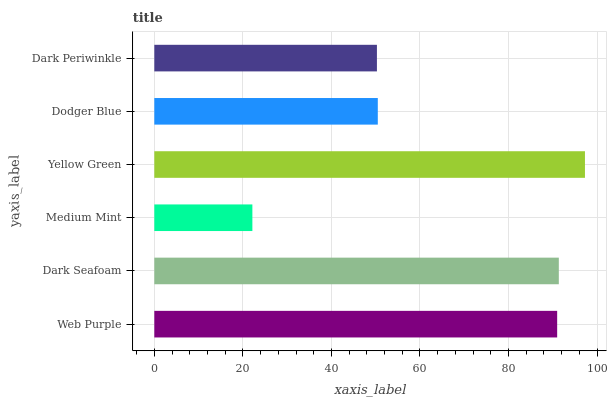Is Medium Mint the minimum?
Answer yes or no. Yes. Is Yellow Green the maximum?
Answer yes or no. Yes. Is Dark Seafoam the minimum?
Answer yes or no. No. Is Dark Seafoam the maximum?
Answer yes or no. No. Is Dark Seafoam greater than Web Purple?
Answer yes or no. Yes. Is Web Purple less than Dark Seafoam?
Answer yes or no. Yes. Is Web Purple greater than Dark Seafoam?
Answer yes or no. No. Is Dark Seafoam less than Web Purple?
Answer yes or no. No. Is Web Purple the high median?
Answer yes or no. Yes. Is Dodger Blue the low median?
Answer yes or no. Yes. Is Yellow Green the high median?
Answer yes or no. No. Is Web Purple the low median?
Answer yes or no. No. 